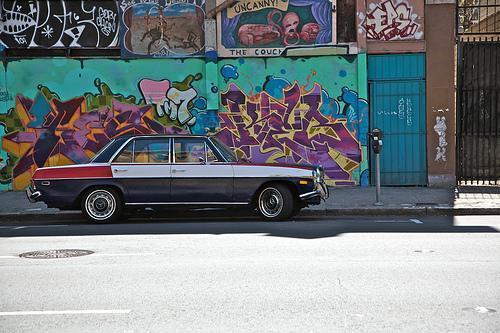How many cars are pictured?
Give a very brief answer. 1. 